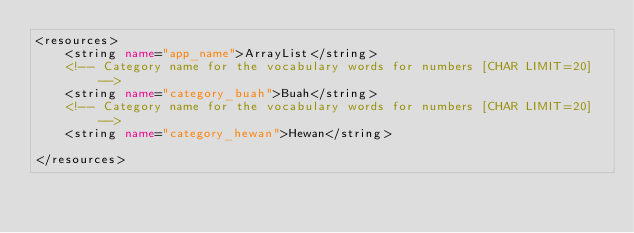Convert code to text. <code><loc_0><loc_0><loc_500><loc_500><_XML_><resources>
    <string name="app_name">ArrayList</string>
    <!-- Category name for the vocabulary words for numbers [CHAR LIMIT=20] -->
    <string name="category_buah">Buah</string>
    <!-- Category name for the vocabulary words for numbers [CHAR LIMIT=20] -->
    <string name="category_hewan">Hewan</string>

</resources>
</code> 